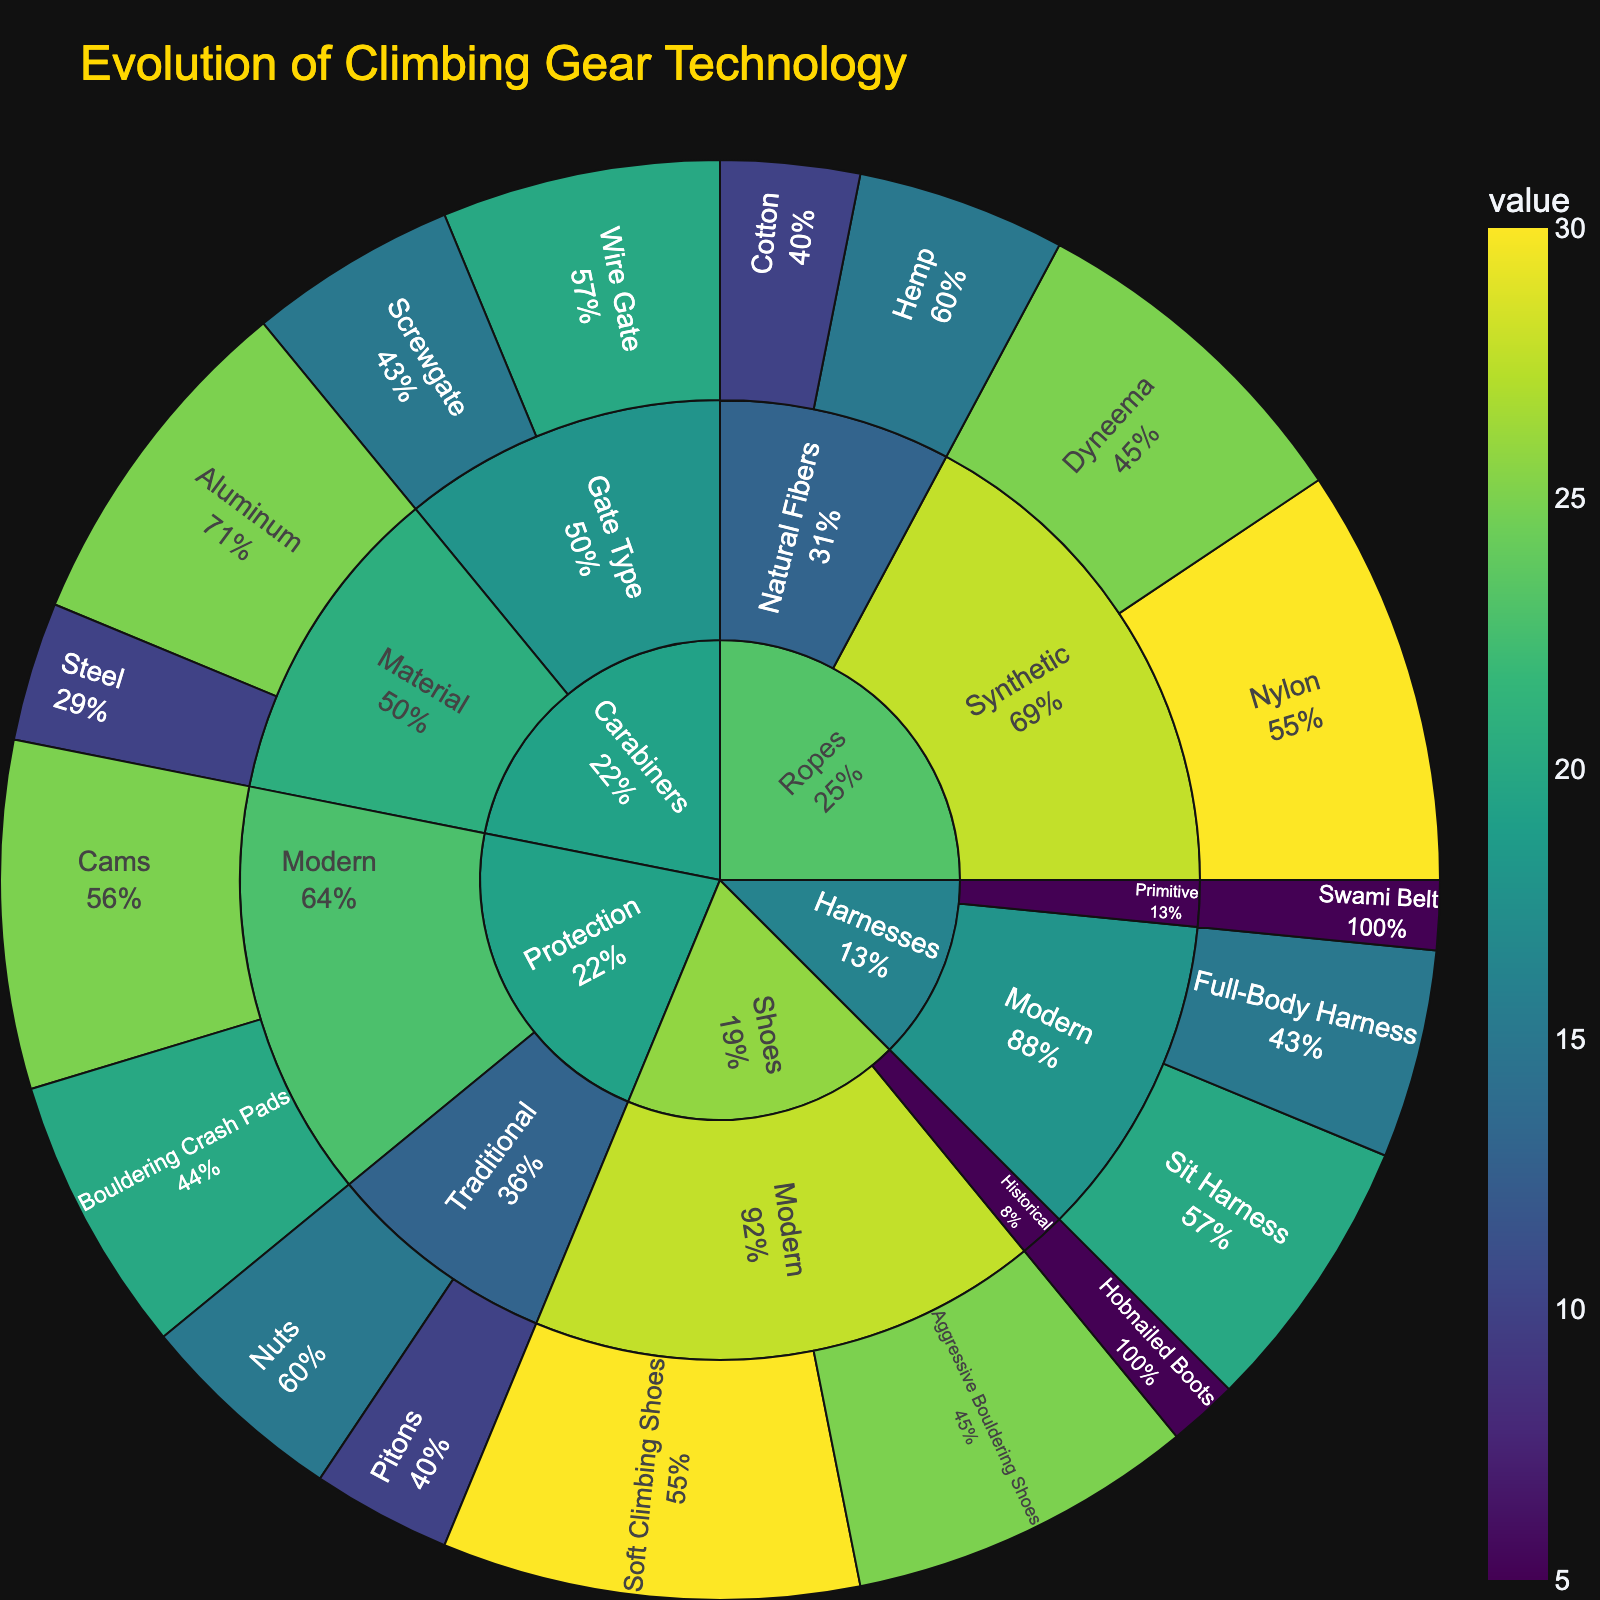what is the title of the plot? The title is usually prominently displayed at the top of the plot. By looking at the top of the figure where the title usually is, you can read "Evolution of Climbing Gear Technology".
Answer: Evolution of Climbing Gear Technology How many total items are there under the category "Ropes"? In the Sunburst Plot, you can trace the branches under "Ropes". The items listed are "Hemp", "Cotton", "Nylon", and "Dyneema", which totals to 4 items.
Answer: 4 Which subcategory of ropes has the highest value? By examining the branches under "Ropes", you see the values for "Natural Fibers" and "Synthetic". Adding them up, "Natural Fibers" = 15 + 10 = 25, and "Synthetic" = 30 + 25 = 55. Therefore, "Synthetic" has the highest value.
Answer: Synthetic What is the value of "Aggressive Bouldering Shoes"? You can locate "Shoes" and then "Modern" to find the value of "Aggressive Bouldering Shoes" in the plot, which is marked as 25.
Answer: 25 Compare the value of "Steel" carabiners with "Aluminum" carabiners. Which is greater and by how much? You can locate "Carabiners" and then follow the "Material" subcategory to find "Steel" with a value of 10 and "Aluminum" with 25. So, 25 - 10 = 15, making "Aluminum" greater by 15.
Answer: Aluminum is greater by 15 What percentage of the total can be attributed to "Nuts" in the "Protection" category? Find the value of "Nuts" under "Protection", which is 15. Sum all values under "Protection” (10 + 15 + 25 + 20 = 70). The percentage is then (15/70) * 100.
Answer: 21.43% How does the value of "Sit Harness" compare to the combined values of "Swami Belt" and "Full-Body Harness"? First, find the values: "Sit Harness" = 20, "Swami Belt" = 5, "Full-Body Harness" = 15. Then compare 20 to (5 + 15 = 20). "Sit Harness" is equal to the combined values of "Swami Belt" and "Full-Body Harness".
Answer: Equal Which item in the "Protection" category has the highest value, and what is it? Scan through items under the "Protection" category, seeing "Pitons" (10), "Nuts" (15), "Cams" (25), and "Bouldering Crash Pads" (20). Hence, the highest value is "Cams" with 25.
Answer: Cams, 25 What is the total value of all items in the "Shoes" category? Sum the values under "Shoes" by locating "Hobnailed Boots" (5), "Soft Climbing Shoes" (30), and "Aggressive Bouldering Shoes" (25). Total = 5 + 30 + 25 = 60.
Answer: 60 